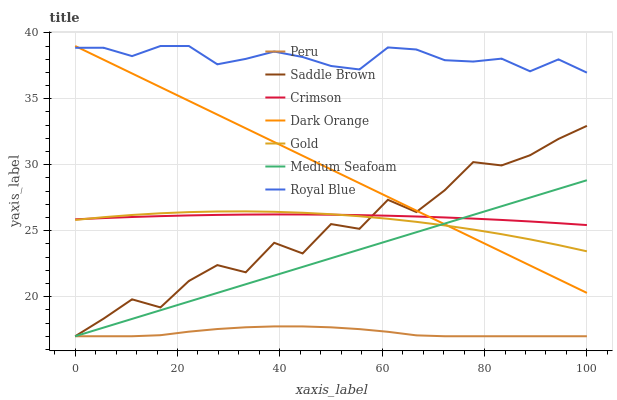Does Gold have the minimum area under the curve?
Answer yes or no. No. Does Gold have the maximum area under the curve?
Answer yes or no. No. Is Gold the smoothest?
Answer yes or no. No. Is Gold the roughest?
Answer yes or no. No. Does Gold have the lowest value?
Answer yes or no. No. Does Gold have the highest value?
Answer yes or no. No. Is Peru less than Dark Orange?
Answer yes or no. Yes. Is Gold greater than Peru?
Answer yes or no. Yes. Does Peru intersect Dark Orange?
Answer yes or no. No. 